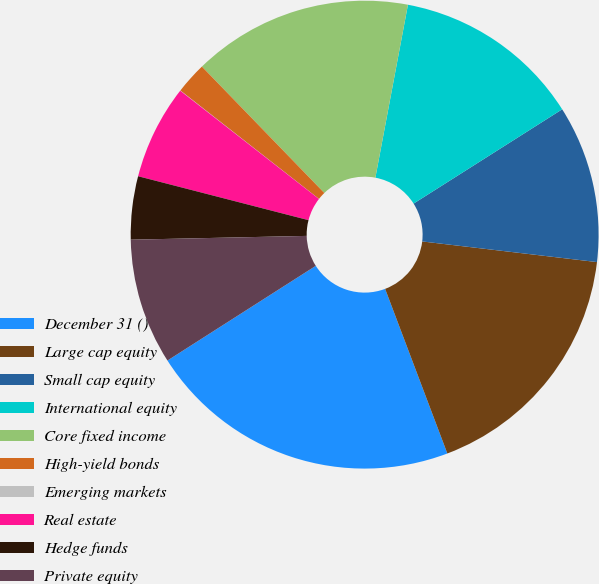Convert chart to OTSL. <chart><loc_0><loc_0><loc_500><loc_500><pie_chart><fcel>December 31 ()<fcel>Large cap equity<fcel>Small cap equity<fcel>International equity<fcel>Core fixed income<fcel>High-yield bonds<fcel>Emerging markets<fcel>Real estate<fcel>Hedge funds<fcel>Private equity<nl><fcel>21.71%<fcel>17.38%<fcel>10.87%<fcel>13.04%<fcel>15.21%<fcel>2.19%<fcel>0.02%<fcel>6.53%<fcel>4.36%<fcel>8.7%<nl></chart> 